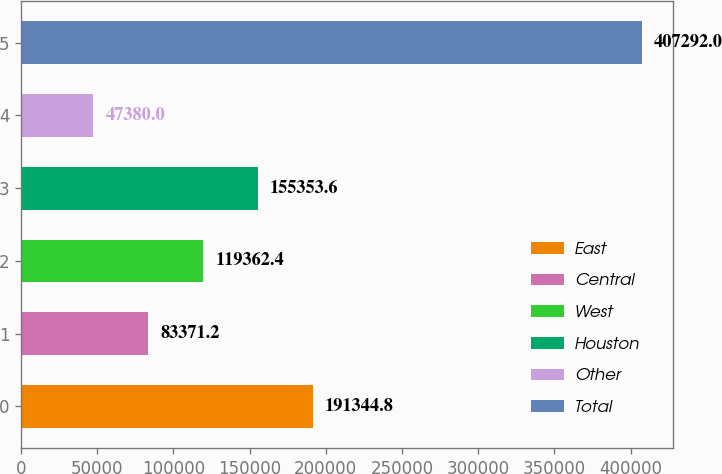Convert chart. <chart><loc_0><loc_0><loc_500><loc_500><bar_chart><fcel>East<fcel>Central<fcel>West<fcel>Houston<fcel>Other<fcel>Total<nl><fcel>191345<fcel>83371.2<fcel>119362<fcel>155354<fcel>47380<fcel>407292<nl></chart> 